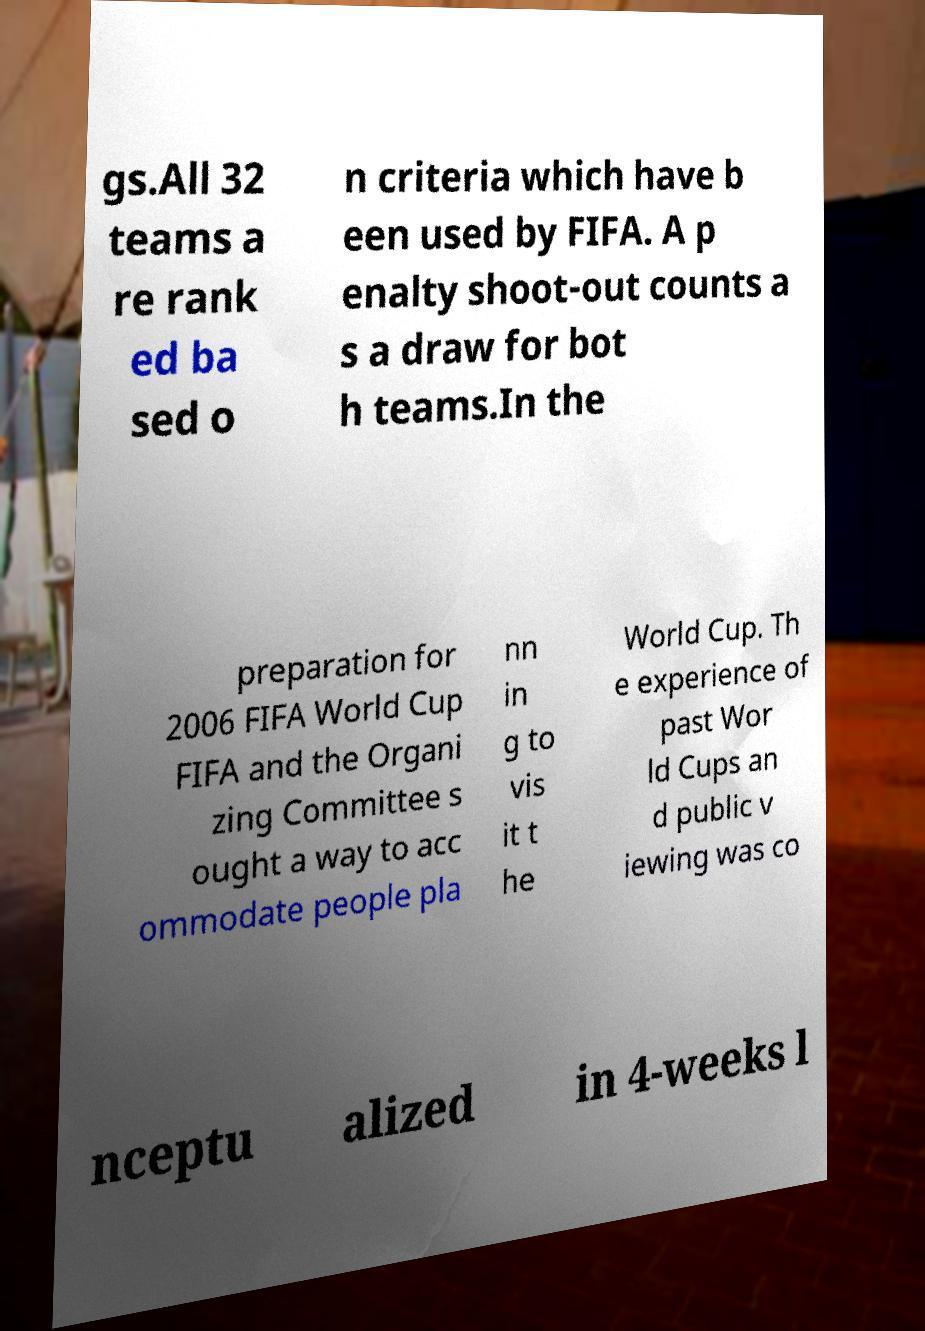Can you read and provide the text displayed in the image?This photo seems to have some interesting text. Can you extract and type it out for me? gs.All 32 teams a re rank ed ba sed o n criteria which have b een used by FIFA. A p enalty shoot-out counts a s a draw for bot h teams.In the preparation for 2006 FIFA World Cup FIFA and the Organi zing Committee s ought a way to acc ommodate people pla nn in g to vis it t he World Cup. Th e experience of past Wor ld Cups an d public v iewing was co nceptu alized in 4-weeks l 